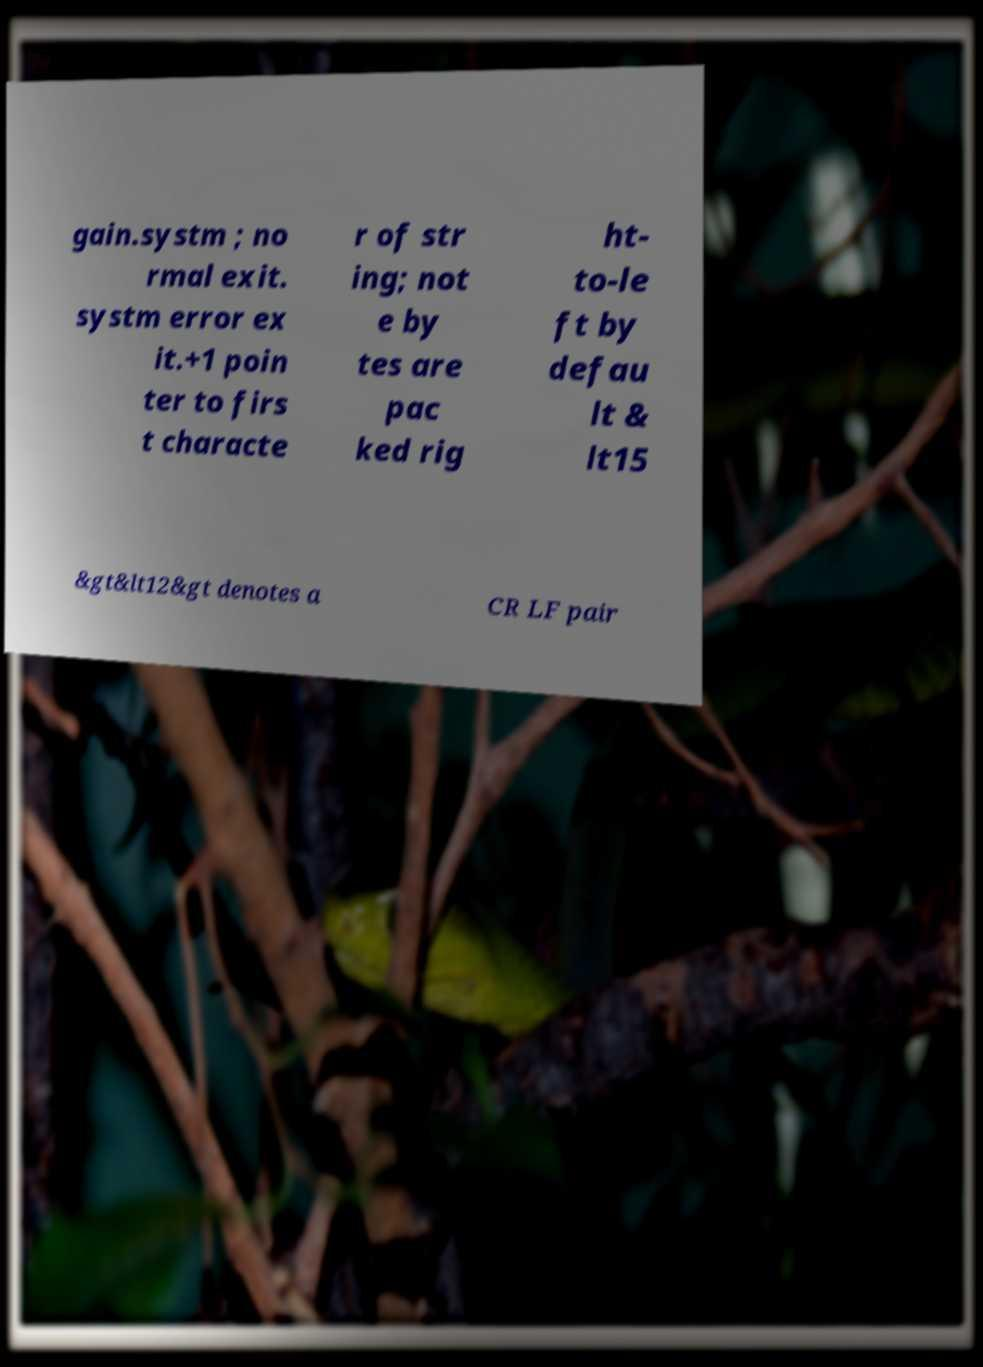Please identify and transcribe the text found in this image. gain.systm ; no rmal exit. systm error ex it.+1 poin ter to firs t characte r of str ing; not e by tes are pac ked rig ht- to-le ft by defau lt & lt15 &gt&lt12&gt denotes a CR LF pair 